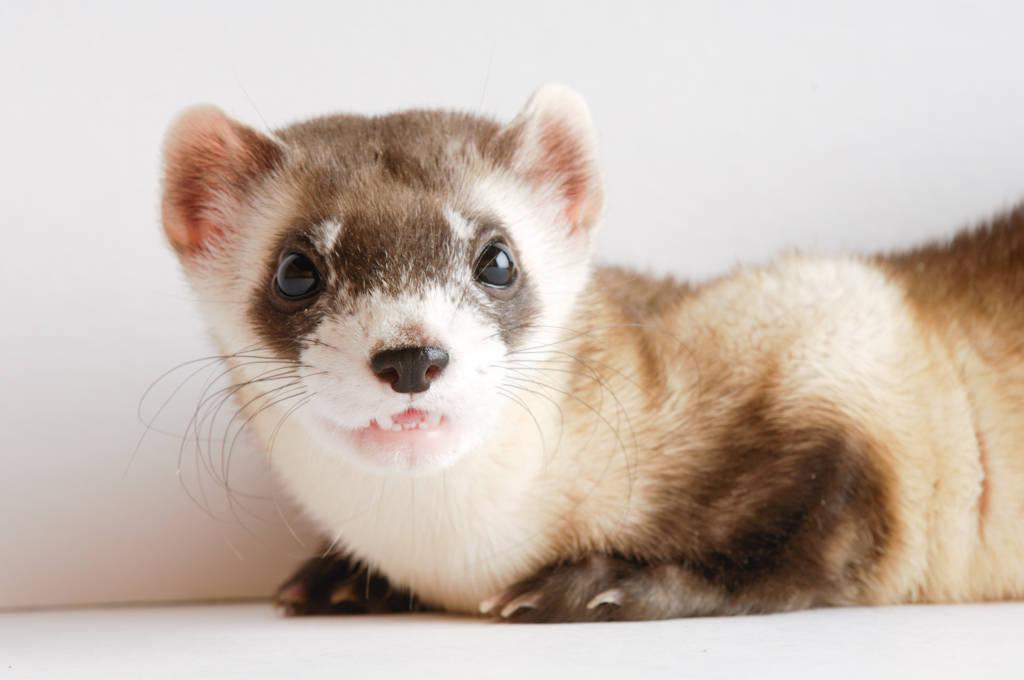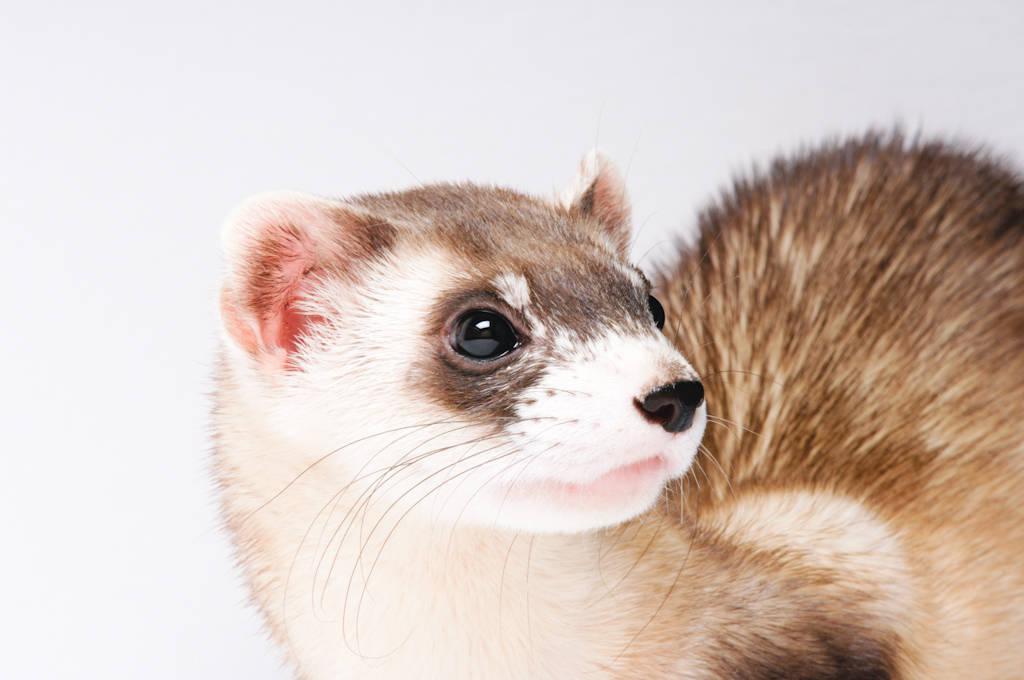The first image is the image on the left, the second image is the image on the right. Evaluate the accuracy of this statement regarding the images: "There is one animal photographed in front of a white background.". Is it true? Answer yes or no. Yes. The first image is the image on the left, the second image is the image on the right. Assess this claim about the two images: "There is an animal that is not a ferret.". Correct or not? Answer yes or no. No. 